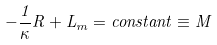Convert formula to latex. <formula><loc_0><loc_0><loc_500><loc_500>- \frac { 1 } { \kappa } R + L _ { m } = c o n s t a n t \equiv M</formula> 